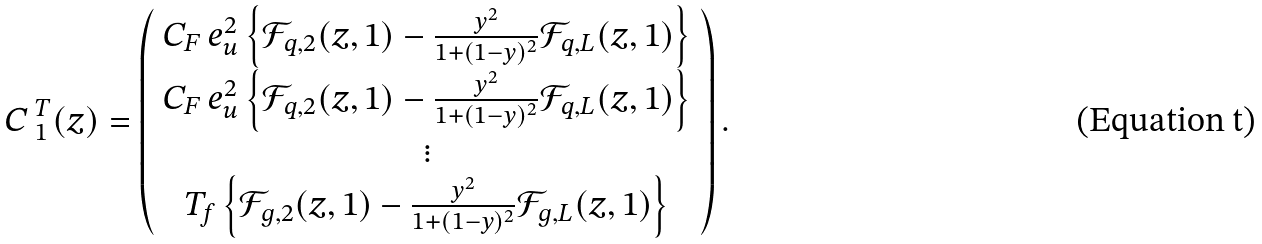Convert formula to latex. <formula><loc_0><loc_0><loc_500><loc_500>\emph { C } _ { 1 } ^ { T } ( z ) = \left ( \begin{array} { c } C _ { F } \, e _ { u } ^ { 2 } \left \{ \mathcal { F } _ { q , 2 } ( z , 1 ) - \frac { y ^ { 2 } } { 1 + ( 1 - y ) ^ { 2 } } \mathcal { F } _ { q , L } ( z , 1 ) \right \} \\ C _ { F } \, e _ { u } ^ { 2 } \left \{ \mathcal { F } _ { q , 2 } ( z , 1 ) - \frac { y ^ { 2 } } { 1 + ( 1 - y ) ^ { 2 } } \mathcal { F } _ { q , L } ( z , 1 ) \right \} \\ \vdots \\ T _ { f } \left \{ \mathcal { F } _ { g , 2 } ( z , 1 ) - \frac { y ^ { 2 } } { 1 + ( 1 - y ) ^ { 2 } } \mathcal { F } _ { g , L } ( z , 1 ) \right \} \\ \end{array} \right ) .</formula> 